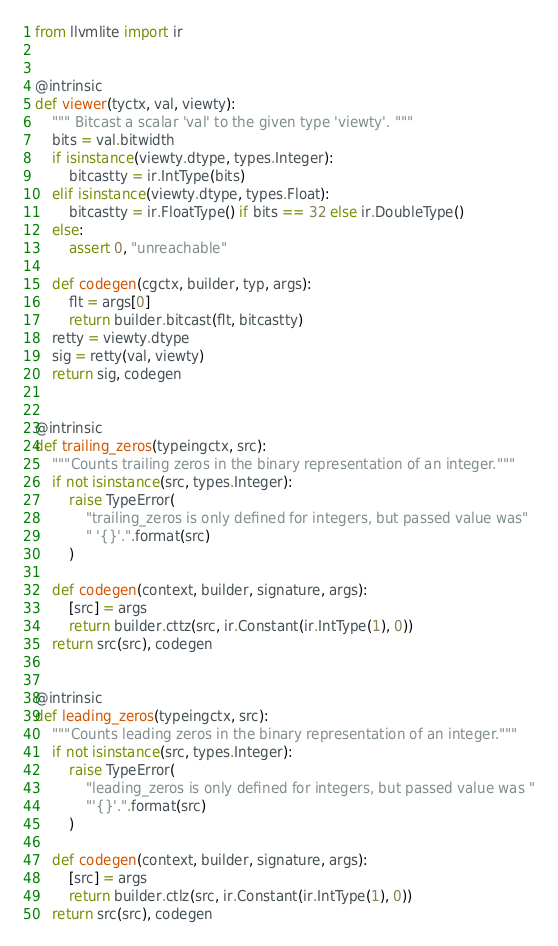Convert code to text. <code><loc_0><loc_0><loc_500><loc_500><_Python_>
from llvmlite import ir


@intrinsic
def viewer(tyctx, val, viewty):
    """ Bitcast a scalar 'val' to the given type 'viewty'. """
    bits = val.bitwidth
    if isinstance(viewty.dtype, types.Integer):
        bitcastty = ir.IntType(bits)
    elif isinstance(viewty.dtype, types.Float):
        bitcastty = ir.FloatType() if bits == 32 else ir.DoubleType()
    else:
        assert 0, "unreachable"

    def codegen(cgctx, builder, typ, args):
        flt = args[0]
        return builder.bitcast(flt, bitcastty)
    retty = viewty.dtype
    sig = retty(val, viewty)
    return sig, codegen


@intrinsic
def trailing_zeros(typeingctx, src):
    """Counts trailing zeros in the binary representation of an integer."""
    if not isinstance(src, types.Integer):
        raise TypeError(
            "trailing_zeros is only defined for integers, but passed value was"
            " '{}'.".format(src)
        )

    def codegen(context, builder, signature, args):
        [src] = args
        return builder.cttz(src, ir.Constant(ir.IntType(1), 0))
    return src(src), codegen


@intrinsic
def leading_zeros(typeingctx, src):
    """Counts leading zeros in the binary representation of an integer."""
    if not isinstance(src, types.Integer):
        raise TypeError(
            "leading_zeros is only defined for integers, but passed value was "
            "'{}'.".format(src)
        )

    def codegen(context, builder, signature, args):
        [src] = args
        return builder.ctlz(src, ir.Constant(ir.IntType(1), 0))
    return src(src), codegen
</code> 